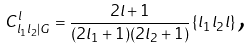<formula> <loc_0><loc_0><loc_500><loc_500>C _ { l _ { 1 } l _ { 2 } | G } ^ { l } = \frac { 2 l + 1 } { ( 2 l _ { 1 } + 1 ) ( 2 l _ { 2 } + 1 ) } \left \{ l _ { 1 } l _ { 2 } l \right \} \text {,}</formula> 